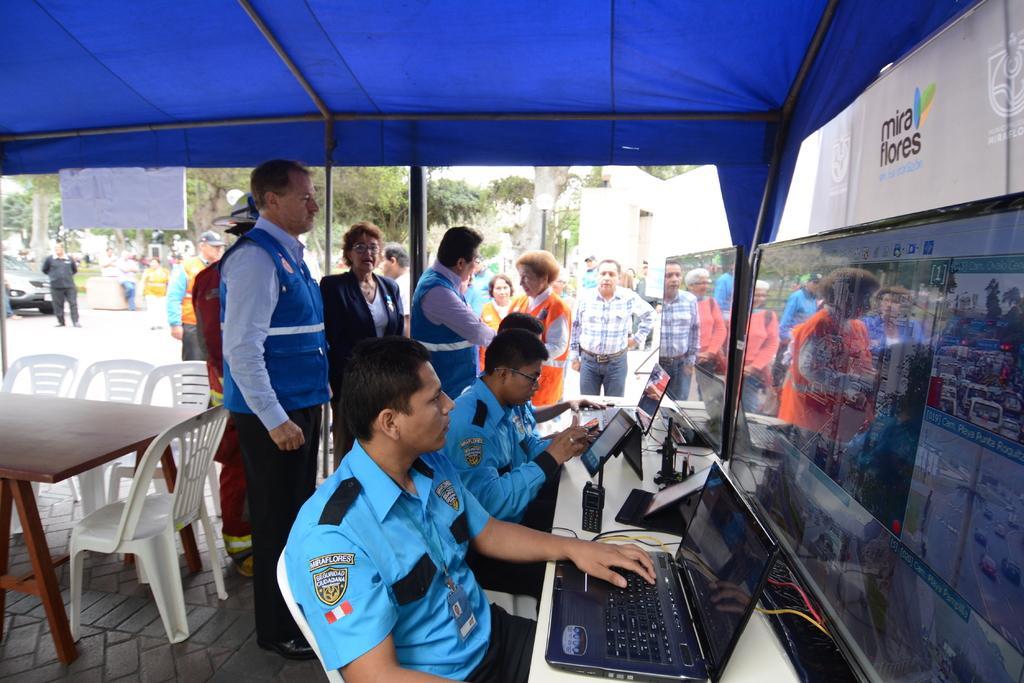In one or two sentences, can you explain what this image depicts? This is a tent under it there are few people and few are sitting on the chair at the table working on laptop. In the background there are vehicles,table,chairs,few people,pole and a building. 